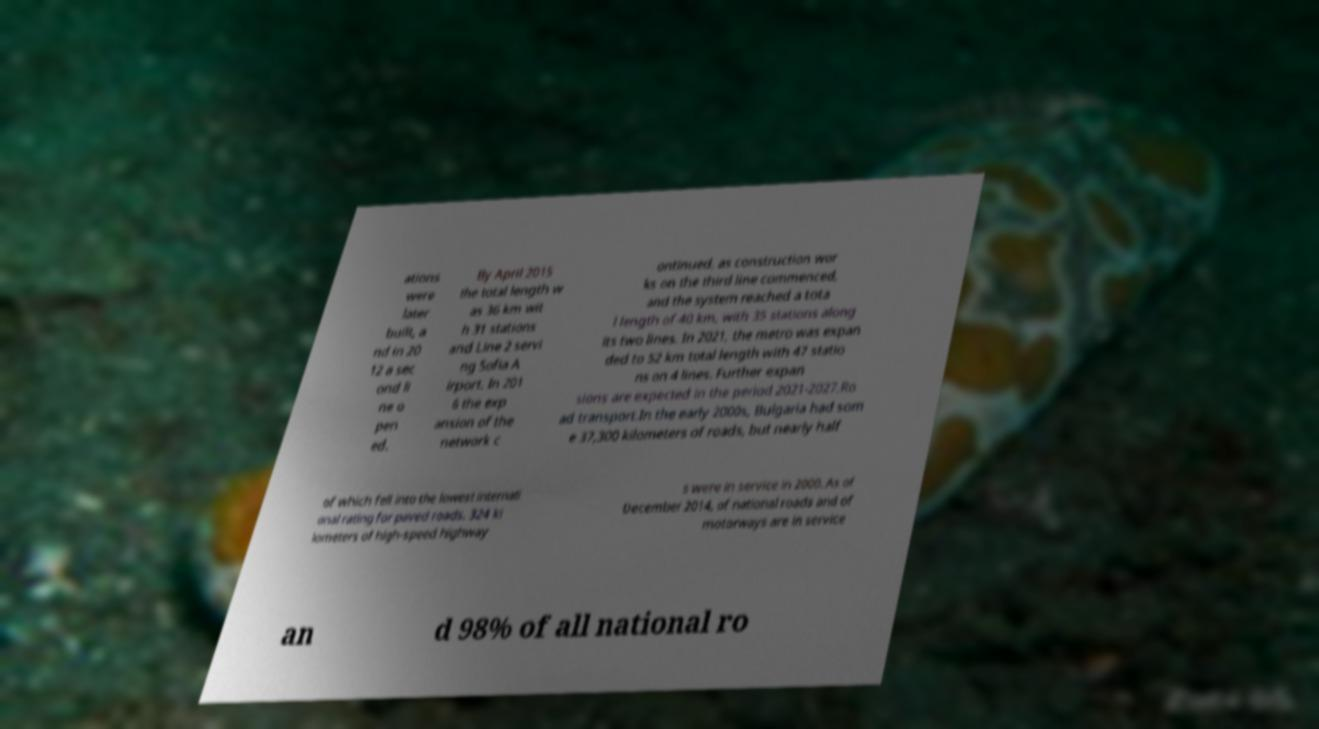Can you read and provide the text displayed in the image?This photo seems to have some interesting text. Can you extract and type it out for me? ations were later built, a nd in 20 12 a sec ond li ne o pen ed. By April 2015 the total length w as 36 km wit h 31 stations and Line 2 servi ng Sofia A irport. In 201 6 the exp ansion of the network c ontinued, as construction wor ks on the third line commenced, and the system reached a tota l length of 40 km, with 35 stations along its two lines. In 2021, the metro was expan ded to 52 km total length with 47 statio ns on 4 lines. Further expan sions are expected in the period 2021-2027.Ro ad transport.In the early 2000s, Bulgaria had som e 37,300 kilometers of roads, but nearly half of which fell into the lowest internati onal rating for paved roads. 324 ki lometers of high-speed highway s were in service in 2000. As of December 2014, of national roads and of motorways are in service an d 98% of all national ro 